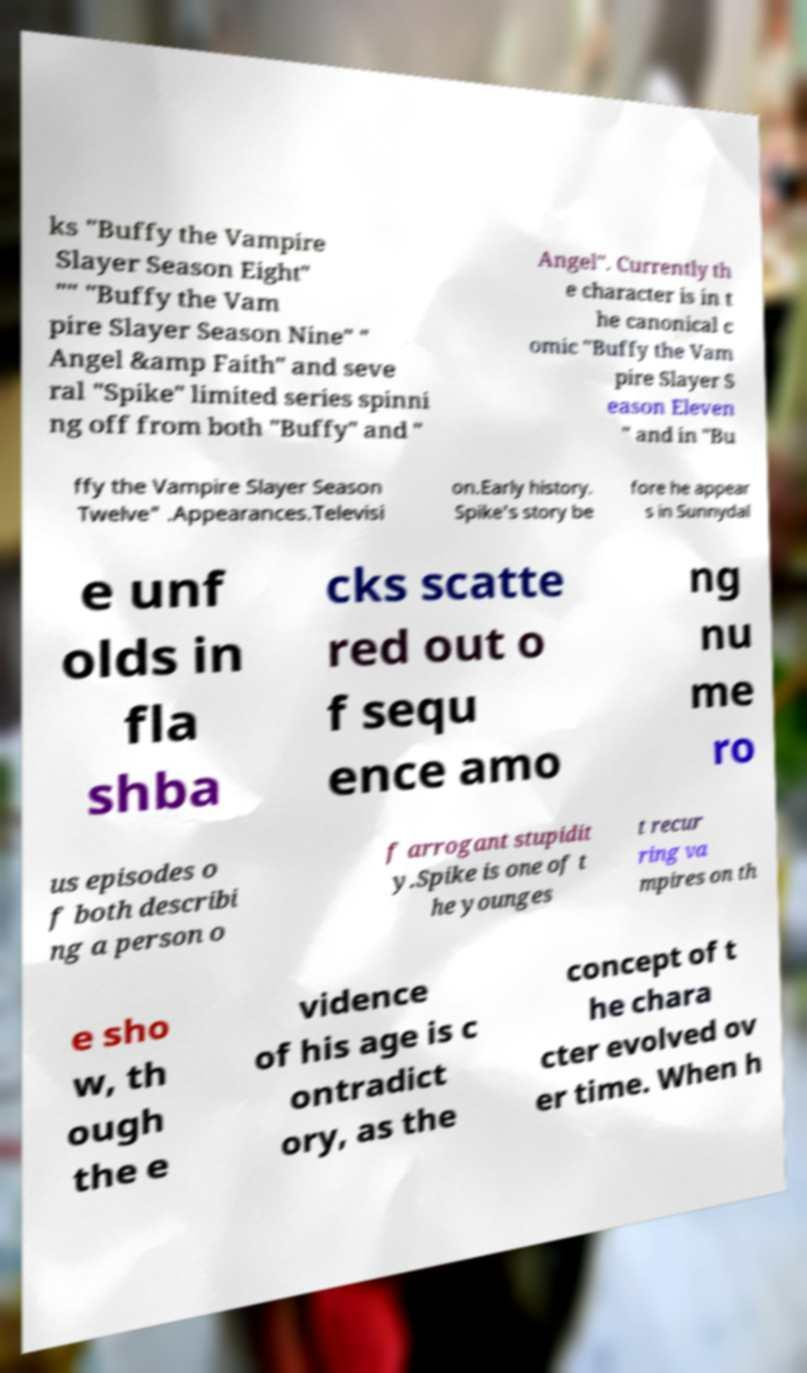Could you assist in decoding the text presented in this image and type it out clearly? ks "Buffy the Vampire Slayer Season Eight" "" "Buffy the Vam pire Slayer Season Nine" " Angel &amp Faith" and seve ral "Spike" limited series spinni ng off from both "Buffy" and " Angel". Currently th e character is in t he canonical c omic "Buffy the Vam pire Slayer S eason Eleven " and in "Bu ffy the Vampire Slayer Season Twelve" .Appearances.Televisi on.Early history. Spike's story be fore he appear s in Sunnydal e unf olds in fla shba cks scatte red out o f sequ ence amo ng nu me ro us episodes o f both describi ng a person o f arrogant stupidit y.Spike is one of t he younges t recur ring va mpires on th e sho w, th ough the e vidence of his age is c ontradict ory, as the concept of t he chara cter evolved ov er time. When h 